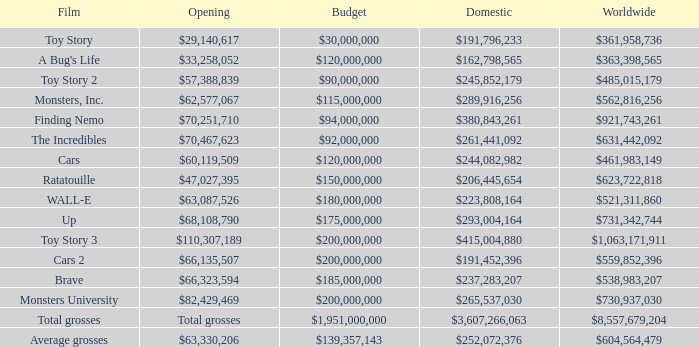WHAT IS THE BUDGET FOR THE INCREDIBLES? $92,000,000. 